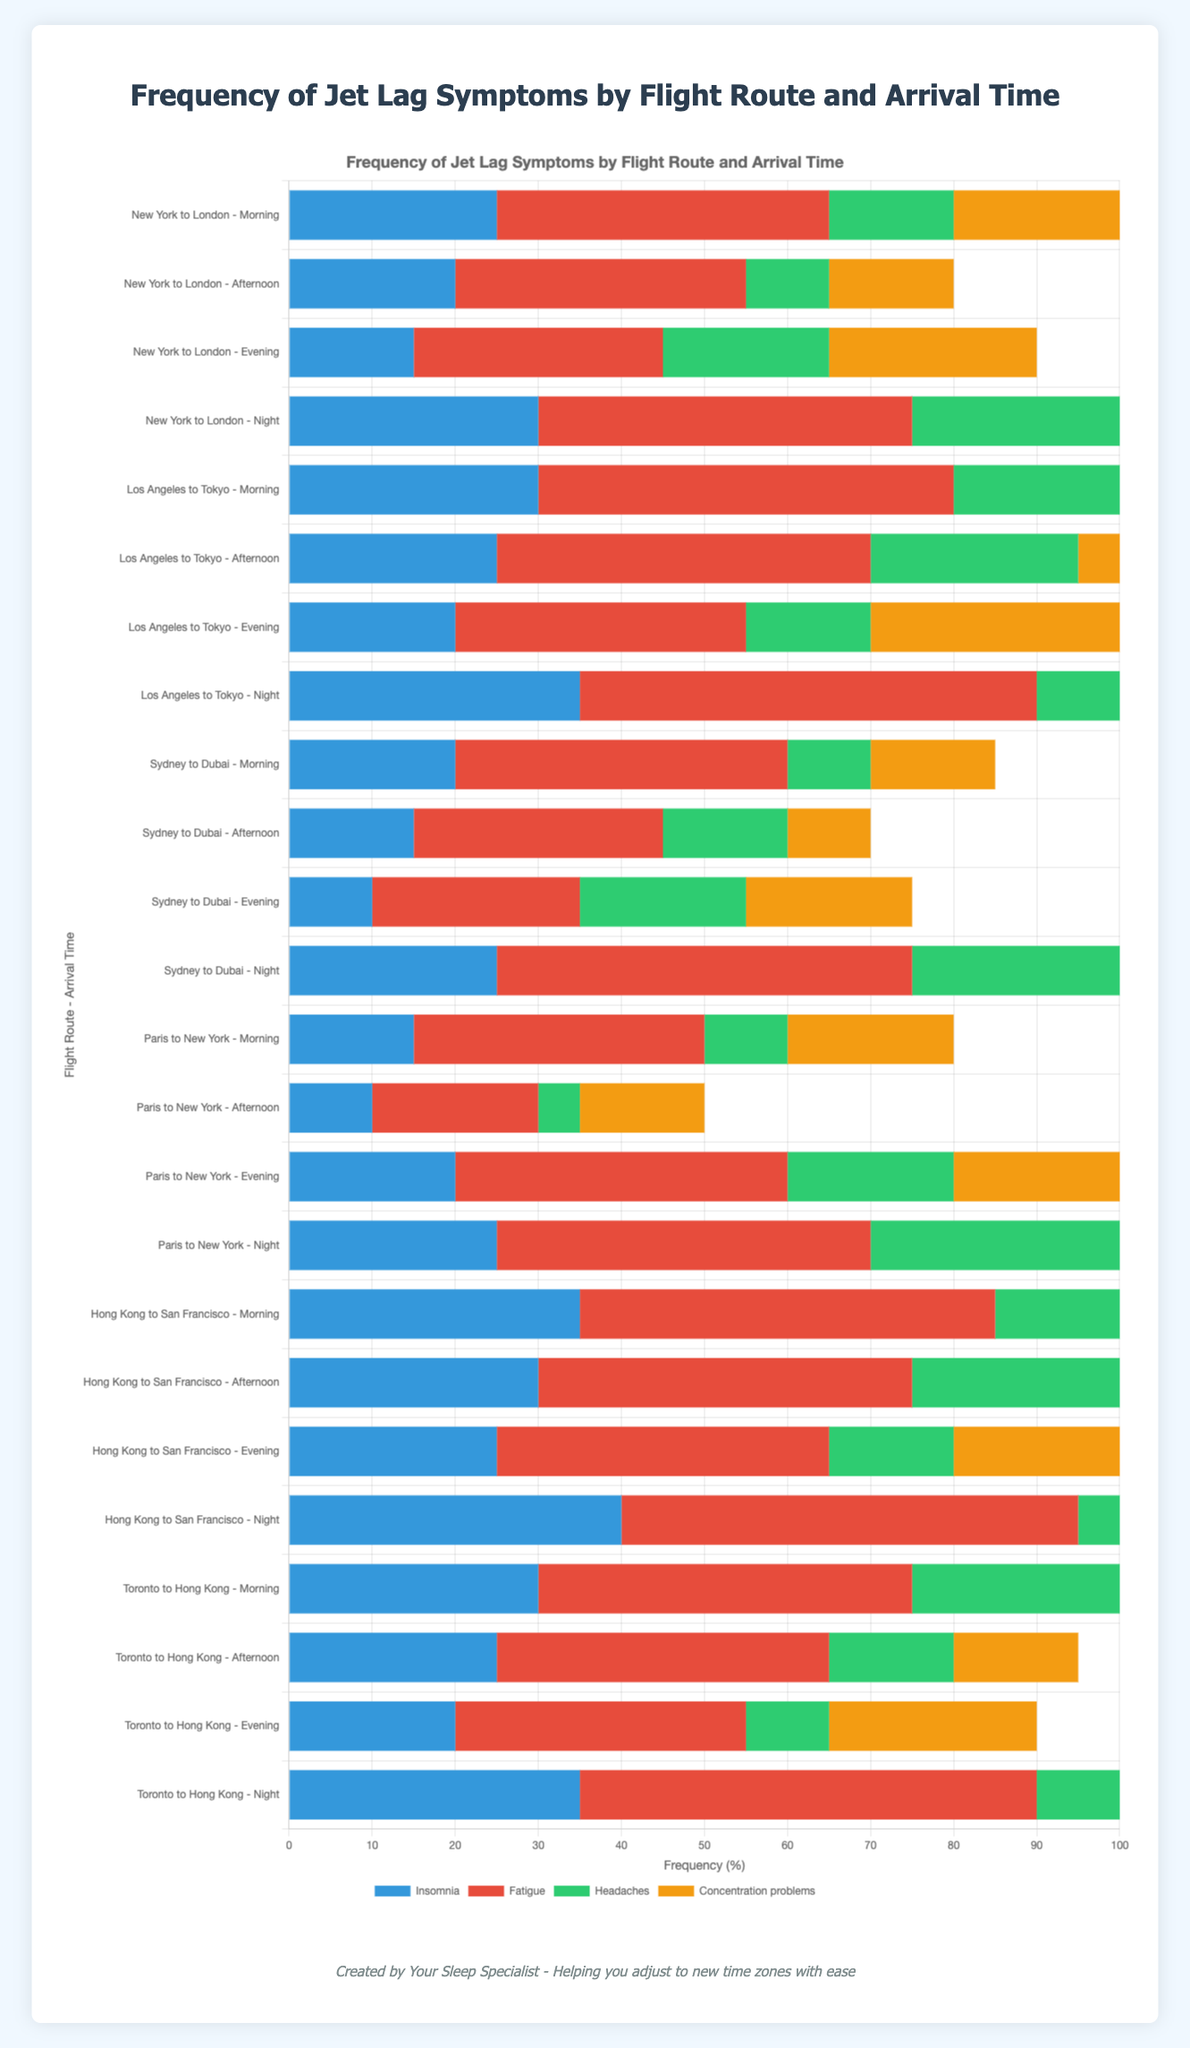What is the total frequency of insomnia for the route "New York to London" when arriving in the morning? The frequency of insomnia for "New York to London" in the morning is shown as 25. Thus the total frequency is simply this value.
Answer: 25 Which route and time of arrival has the highest frequency of fatigue? To determine which combination has the highest frequency of fatigue, scan across all routes and times of arrival. The route "Hong Kong to San Francisco" with an arrival at night has the highest fatigue frequency at 55.
Answer: Hong Kong to San Francisco - Night Compare the frequency of concentration problems for "Los Angeles to Tokyo" arriving in the evening versus "Paris to New York" arriving at night. Which is higher? For "Los Angeles to Tokyo" arriving in the evening, the frequency is 30. For "Paris to New York" arriving at night, the frequency is 35. Thus, the latter is higher.
Answer: Paris to New York - Night What's the average frequency of headaches for the route "Sydney to Dubai" across all times of arrival? To find the average, take the sum of the frequencies for "Sydney to Dubai": 10 (morning) + 15 (afternoon) + 20 (evening) + 30 (night) which totals to 75, and divide by the 4 time slots: 75/4 = 18.75.
Answer: 18.75 Visualizing the chart, which symptom is represented by the green color? Examining the legend of the chart, the symptom represented by the green color is “Fatigue”.
Answer: Fatigue How does the frequency of insomnia on the route "Toronto to Hong Kong" arriving in the morning compare to the frequency of insomnia for "New York to London" arriving at night? "Toronto to Hong Kong" in the morning has an insomnia frequency of 30, while "New York to London" at night has a frequency of 30. Both frequencies are the same.
Answer: Equal Which route and time of arrival has the lowest frequency of any symptom? By scanning through the chart, "Paris to New York" in the afternoon has the lowest frequency of headaches at 5 among all symptoms accounted.
Answer: Paris to New York - Afternoon If you sum up the frequency of concentration problems for all routes arriving in the evening, what is the total? Total concentration problem frequencies for evening arrivals: 25 (New York to London) + 30 (Los Angeles to Tokyo) + 20 (Sydney to Dubai) + 25 (Paris to New York) + 20 (Hong Kong to San Francisco) + 25 (Toronto to Hong Kong) = 145.
Answer: 145 